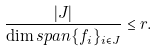Convert formula to latex. <formula><loc_0><loc_0><loc_500><loc_500>\frac { | J | } { \dim s p a n \{ f _ { i } \} _ { i \in J } } \leq r .</formula> 